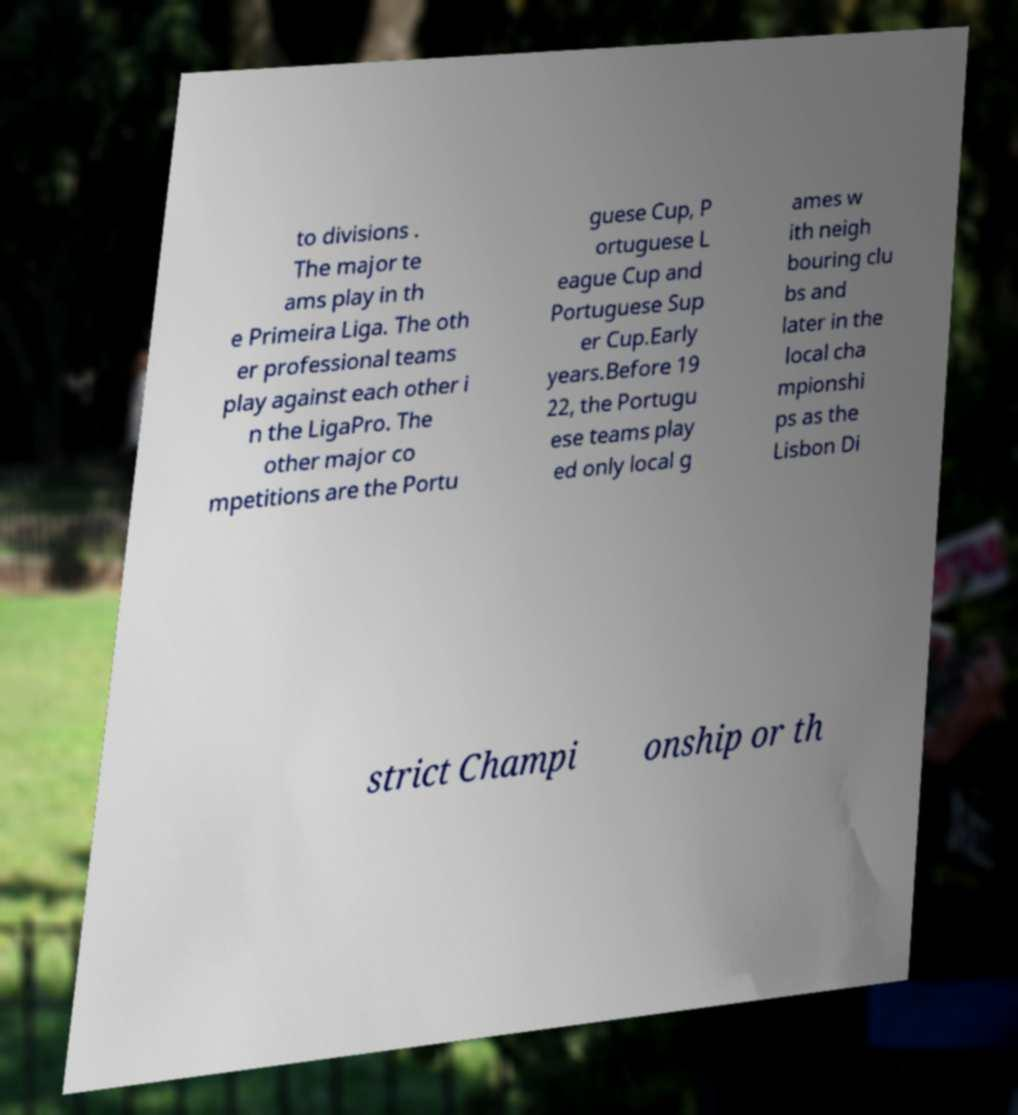What messages or text are displayed in this image? I need them in a readable, typed format. to divisions . The major te ams play in th e Primeira Liga. The oth er professional teams play against each other i n the LigaPro. The other major co mpetitions are the Portu guese Cup, P ortuguese L eague Cup and Portuguese Sup er Cup.Early years.Before 19 22, the Portugu ese teams play ed only local g ames w ith neigh bouring clu bs and later in the local cha mpionshi ps as the Lisbon Di strict Champi onship or th 